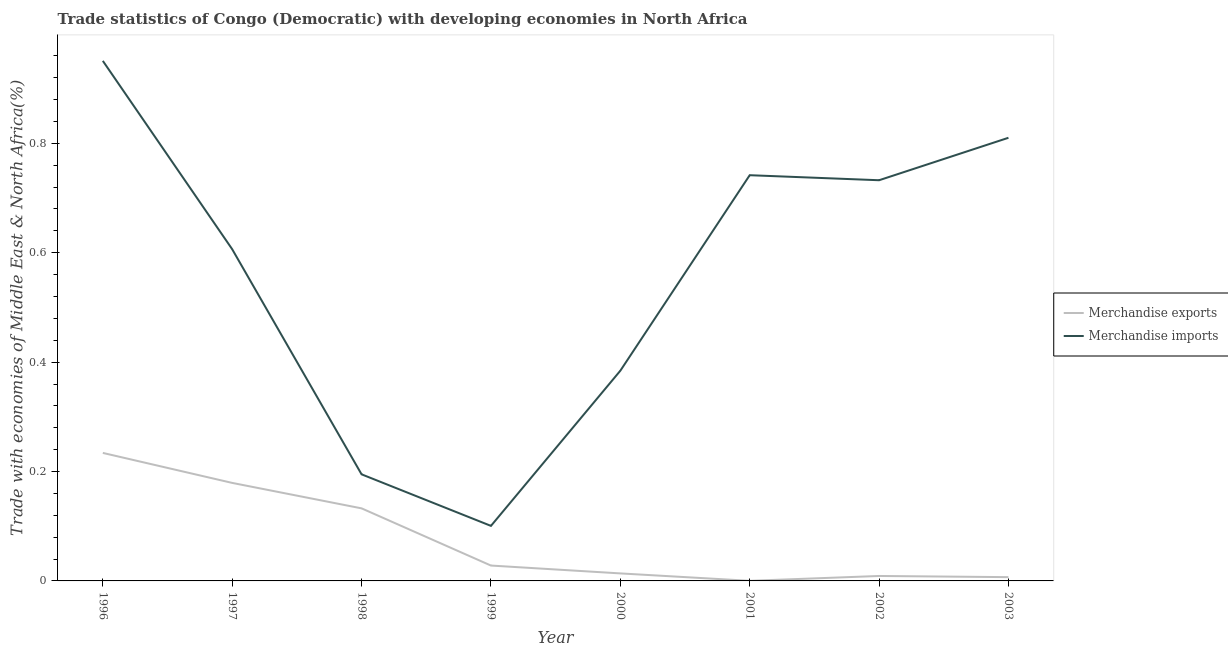What is the merchandise imports in 2003?
Give a very brief answer. 0.81. Across all years, what is the maximum merchandise exports?
Your response must be concise. 0.23. Across all years, what is the minimum merchandise imports?
Provide a succinct answer. 0.1. What is the total merchandise exports in the graph?
Offer a very short reply. 0.6. What is the difference between the merchandise imports in 2000 and that in 2001?
Offer a very short reply. -0.36. What is the difference between the merchandise imports in 2003 and the merchandise exports in 2000?
Give a very brief answer. 0.8. What is the average merchandise exports per year?
Provide a succinct answer. 0.08. In the year 1999, what is the difference between the merchandise imports and merchandise exports?
Give a very brief answer. 0.07. In how many years, is the merchandise imports greater than 0.32 %?
Make the answer very short. 6. What is the ratio of the merchandise imports in 1999 to that in 2002?
Your response must be concise. 0.14. Is the difference between the merchandise imports in 2001 and 2002 greater than the difference between the merchandise exports in 2001 and 2002?
Your response must be concise. Yes. What is the difference between the highest and the second highest merchandise imports?
Offer a very short reply. 0.14. What is the difference between the highest and the lowest merchandise exports?
Your answer should be very brief. 0.23. Is the sum of the merchandise imports in 1998 and 2000 greater than the maximum merchandise exports across all years?
Give a very brief answer. Yes. Does the merchandise imports monotonically increase over the years?
Offer a terse response. No. Is the merchandise exports strictly greater than the merchandise imports over the years?
Provide a short and direct response. No. Is the merchandise imports strictly less than the merchandise exports over the years?
Provide a succinct answer. No. How many years are there in the graph?
Make the answer very short. 8. Are the values on the major ticks of Y-axis written in scientific E-notation?
Keep it short and to the point. No. Does the graph contain any zero values?
Provide a short and direct response. No. Where does the legend appear in the graph?
Provide a short and direct response. Center right. How are the legend labels stacked?
Your response must be concise. Vertical. What is the title of the graph?
Keep it short and to the point. Trade statistics of Congo (Democratic) with developing economies in North Africa. What is the label or title of the X-axis?
Your answer should be very brief. Year. What is the label or title of the Y-axis?
Keep it short and to the point. Trade with economies of Middle East & North Africa(%). What is the Trade with economies of Middle East & North Africa(%) of Merchandise exports in 1996?
Provide a short and direct response. 0.23. What is the Trade with economies of Middle East & North Africa(%) of Merchandise imports in 1996?
Offer a terse response. 0.95. What is the Trade with economies of Middle East & North Africa(%) of Merchandise exports in 1997?
Provide a short and direct response. 0.18. What is the Trade with economies of Middle East & North Africa(%) of Merchandise imports in 1997?
Offer a very short reply. 0.61. What is the Trade with economies of Middle East & North Africa(%) of Merchandise exports in 1998?
Make the answer very short. 0.13. What is the Trade with economies of Middle East & North Africa(%) in Merchandise imports in 1998?
Keep it short and to the point. 0.19. What is the Trade with economies of Middle East & North Africa(%) in Merchandise exports in 1999?
Your response must be concise. 0.03. What is the Trade with economies of Middle East & North Africa(%) in Merchandise imports in 1999?
Provide a succinct answer. 0.1. What is the Trade with economies of Middle East & North Africa(%) of Merchandise exports in 2000?
Provide a short and direct response. 0.01. What is the Trade with economies of Middle East & North Africa(%) of Merchandise imports in 2000?
Make the answer very short. 0.38. What is the Trade with economies of Middle East & North Africa(%) in Merchandise exports in 2001?
Your answer should be very brief. 0. What is the Trade with economies of Middle East & North Africa(%) in Merchandise imports in 2001?
Provide a short and direct response. 0.74. What is the Trade with economies of Middle East & North Africa(%) of Merchandise exports in 2002?
Provide a succinct answer. 0.01. What is the Trade with economies of Middle East & North Africa(%) of Merchandise imports in 2002?
Your answer should be very brief. 0.73. What is the Trade with economies of Middle East & North Africa(%) of Merchandise exports in 2003?
Provide a short and direct response. 0.01. What is the Trade with economies of Middle East & North Africa(%) of Merchandise imports in 2003?
Give a very brief answer. 0.81. Across all years, what is the maximum Trade with economies of Middle East & North Africa(%) of Merchandise exports?
Offer a very short reply. 0.23. Across all years, what is the maximum Trade with economies of Middle East & North Africa(%) in Merchandise imports?
Provide a succinct answer. 0.95. Across all years, what is the minimum Trade with economies of Middle East & North Africa(%) in Merchandise exports?
Give a very brief answer. 0. Across all years, what is the minimum Trade with economies of Middle East & North Africa(%) of Merchandise imports?
Give a very brief answer. 0.1. What is the total Trade with economies of Middle East & North Africa(%) in Merchandise exports in the graph?
Make the answer very short. 0.6. What is the total Trade with economies of Middle East & North Africa(%) of Merchandise imports in the graph?
Your response must be concise. 4.52. What is the difference between the Trade with economies of Middle East & North Africa(%) of Merchandise exports in 1996 and that in 1997?
Offer a terse response. 0.05. What is the difference between the Trade with economies of Middle East & North Africa(%) of Merchandise imports in 1996 and that in 1997?
Offer a very short reply. 0.34. What is the difference between the Trade with economies of Middle East & North Africa(%) of Merchandise exports in 1996 and that in 1998?
Your response must be concise. 0.1. What is the difference between the Trade with economies of Middle East & North Africa(%) in Merchandise imports in 1996 and that in 1998?
Provide a short and direct response. 0.76. What is the difference between the Trade with economies of Middle East & North Africa(%) in Merchandise exports in 1996 and that in 1999?
Ensure brevity in your answer.  0.21. What is the difference between the Trade with economies of Middle East & North Africa(%) of Merchandise imports in 1996 and that in 1999?
Give a very brief answer. 0.85. What is the difference between the Trade with economies of Middle East & North Africa(%) of Merchandise exports in 1996 and that in 2000?
Your response must be concise. 0.22. What is the difference between the Trade with economies of Middle East & North Africa(%) in Merchandise imports in 1996 and that in 2000?
Your answer should be very brief. 0.57. What is the difference between the Trade with economies of Middle East & North Africa(%) in Merchandise exports in 1996 and that in 2001?
Your response must be concise. 0.23. What is the difference between the Trade with economies of Middle East & North Africa(%) in Merchandise imports in 1996 and that in 2001?
Offer a terse response. 0.21. What is the difference between the Trade with economies of Middle East & North Africa(%) in Merchandise exports in 1996 and that in 2002?
Provide a short and direct response. 0.23. What is the difference between the Trade with economies of Middle East & North Africa(%) of Merchandise imports in 1996 and that in 2002?
Your answer should be very brief. 0.22. What is the difference between the Trade with economies of Middle East & North Africa(%) in Merchandise exports in 1996 and that in 2003?
Keep it short and to the point. 0.23. What is the difference between the Trade with economies of Middle East & North Africa(%) in Merchandise imports in 1996 and that in 2003?
Provide a short and direct response. 0.14. What is the difference between the Trade with economies of Middle East & North Africa(%) of Merchandise exports in 1997 and that in 1998?
Offer a terse response. 0.05. What is the difference between the Trade with economies of Middle East & North Africa(%) of Merchandise imports in 1997 and that in 1998?
Provide a succinct answer. 0.41. What is the difference between the Trade with economies of Middle East & North Africa(%) of Merchandise exports in 1997 and that in 1999?
Provide a succinct answer. 0.15. What is the difference between the Trade with economies of Middle East & North Africa(%) in Merchandise imports in 1997 and that in 1999?
Your response must be concise. 0.51. What is the difference between the Trade with economies of Middle East & North Africa(%) of Merchandise exports in 1997 and that in 2000?
Your response must be concise. 0.17. What is the difference between the Trade with economies of Middle East & North Africa(%) in Merchandise imports in 1997 and that in 2000?
Provide a short and direct response. 0.22. What is the difference between the Trade with economies of Middle East & North Africa(%) in Merchandise exports in 1997 and that in 2001?
Your answer should be compact. 0.18. What is the difference between the Trade with economies of Middle East & North Africa(%) in Merchandise imports in 1997 and that in 2001?
Provide a short and direct response. -0.14. What is the difference between the Trade with economies of Middle East & North Africa(%) of Merchandise exports in 1997 and that in 2002?
Offer a very short reply. 0.17. What is the difference between the Trade with economies of Middle East & North Africa(%) in Merchandise imports in 1997 and that in 2002?
Give a very brief answer. -0.13. What is the difference between the Trade with economies of Middle East & North Africa(%) of Merchandise exports in 1997 and that in 2003?
Your response must be concise. 0.17. What is the difference between the Trade with economies of Middle East & North Africa(%) of Merchandise imports in 1997 and that in 2003?
Your response must be concise. -0.2. What is the difference between the Trade with economies of Middle East & North Africa(%) of Merchandise exports in 1998 and that in 1999?
Your answer should be compact. 0.1. What is the difference between the Trade with economies of Middle East & North Africa(%) in Merchandise imports in 1998 and that in 1999?
Provide a short and direct response. 0.09. What is the difference between the Trade with economies of Middle East & North Africa(%) in Merchandise exports in 1998 and that in 2000?
Provide a short and direct response. 0.12. What is the difference between the Trade with economies of Middle East & North Africa(%) of Merchandise imports in 1998 and that in 2000?
Give a very brief answer. -0.19. What is the difference between the Trade with economies of Middle East & North Africa(%) in Merchandise exports in 1998 and that in 2001?
Keep it short and to the point. 0.13. What is the difference between the Trade with economies of Middle East & North Africa(%) of Merchandise imports in 1998 and that in 2001?
Offer a terse response. -0.55. What is the difference between the Trade with economies of Middle East & North Africa(%) of Merchandise exports in 1998 and that in 2002?
Give a very brief answer. 0.12. What is the difference between the Trade with economies of Middle East & North Africa(%) of Merchandise imports in 1998 and that in 2002?
Ensure brevity in your answer.  -0.54. What is the difference between the Trade with economies of Middle East & North Africa(%) of Merchandise exports in 1998 and that in 2003?
Make the answer very short. 0.13. What is the difference between the Trade with economies of Middle East & North Africa(%) of Merchandise imports in 1998 and that in 2003?
Your response must be concise. -0.62. What is the difference between the Trade with economies of Middle East & North Africa(%) of Merchandise exports in 1999 and that in 2000?
Keep it short and to the point. 0.01. What is the difference between the Trade with economies of Middle East & North Africa(%) of Merchandise imports in 1999 and that in 2000?
Provide a short and direct response. -0.28. What is the difference between the Trade with economies of Middle East & North Africa(%) in Merchandise exports in 1999 and that in 2001?
Provide a succinct answer. 0.03. What is the difference between the Trade with economies of Middle East & North Africa(%) of Merchandise imports in 1999 and that in 2001?
Give a very brief answer. -0.64. What is the difference between the Trade with economies of Middle East & North Africa(%) in Merchandise exports in 1999 and that in 2002?
Keep it short and to the point. 0.02. What is the difference between the Trade with economies of Middle East & North Africa(%) in Merchandise imports in 1999 and that in 2002?
Offer a very short reply. -0.63. What is the difference between the Trade with economies of Middle East & North Africa(%) in Merchandise exports in 1999 and that in 2003?
Ensure brevity in your answer.  0.02. What is the difference between the Trade with economies of Middle East & North Africa(%) of Merchandise imports in 1999 and that in 2003?
Your answer should be very brief. -0.71. What is the difference between the Trade with economies of Middle East & North Africa(%) of Merchandise exports in 2000 and that in 2001?
Provide a short and direct response. 0.01. What is the difference between the Trade with economies of Middle East & North Africa(%) in Merchandise imports in 2000 and that in 2001?
Make the answer very short. -0.36. What is the difference between the Trade with economies of Middle East & North Africa(%) of Merchandise exports in 2000 and that in 2002?
Keep it short and to the point. 0. What is the difference between the Trade with economies of Middle East & North Africa(%) in Merchandise imports in 2000 and that in 2002?
Ensure brevity in your answer.  -0.35. What is the difference between the Trade with economies of Middle East & North Africa(%) of Merchandise exports in 2000 and that in 2003?
Provide a succinct answer. 0.01. What is the difference between the Trade with economies of Middle East & North Africa(%) in Merchandise imports in 2000 and that in 2003?
Your answer should be very brief. -0.43. What is the difference between the Trade with economies of Middle East & North Africa(%) in Merchandise exports in 2001 and that in 2002?
Ensure brevity in your answer.  -0.01. What is the difference between the Trade with economies of Middle East & North Africa(%) in Merchandise imports in 2001 and that in 2002?
Your answer should be very brief. 0.01. What is the difference between the Trade with economies of Middle East & North Africa(%) of Merchandise exports in 2001 and that in 2003?
Offer a terse response. -0.01. What is the difference between the Trade with economies of Middle East & North Africa(%) of Merchandise imports in 2001 and that in 2003?
Make the answer very short. -0.07. What is the difference between the Trade with economies of Middle East & North Africa(%) in Merchandise exports in 2002 and that in 2003?
Provide a succinct answer. 0. What is the difference between the Trade with economies of Middle East & North Africa(%) of Merchandise imports in 2002 and that in 2003?
Ensure brevity in your answer.  -0.08. What is the difference between the Trade with economies of Middle East & North Africa(%) in Merchandise exports in 1996 and the Trade with economies of Middle East & North Africa(%) in Merchandise imports in 1997?
Provide a succinct answer. -0.37. What is the difference between the Trade with economies of Middle East & North Africa(%) of Merchandise exports in 1996 and the Trade with economies of Middle East & North Africa(%) of Merchandise imports in 1998?
Your response must be concise. 0.04. What is the difference between the Trade with economies of Middle East & North Africa(%) of Merchandise exports in 1996 and the Trade with economies of Middle East & North Africa(%) of Merchandise imports in 1999?
Your answer should be compact. 0.13. What is the difference between the Trade with economies of Middle East & North Africa(%) in Merchandise exports in 1996 and the Trade with economies of Middle East & North Africa(%) in Merchandise imports in 2000?
Your response must be concise. -0.15. What is the difference between the Trade with economies of Middle East & North Africa(%) of Merchandise exports in 1996 and the Trade with economies of Middle East & North Africa(%) of Merchandise imports in 2001?
Give a very brief answer. -0.51. What is the difference between the Trade with economies of Middle East & North Africa(%) in Merchandise exports in 1996 and the Trade with economies of Middle East & North Africa(%) in Merchandise imports in 2002?
Give a very brief answer. -0.5. What is the difference between the Trade with economies of Middle East & North Africa(%) in Merchandise exports in 1996 and the Trade with economies of Middle East & North Africa(%) in Merchandise imports in 2003?
Make the answer very short. -0.58. What is the difference between the Trade with economies of Middle East & North Africa(%) of Merchandise exports in 1997 and the Trade with economies of Middle East & North Africa(%) of Merchandise imports in 1998?
Your answer should be very brief. -0.02. What is the difference between the Trade with economies of Middle East & North Africa(%) of Merchandise exports in 1997 and the Trade with economies of Middle East & North Africa(%) of Merchandise imports in 1999?
Provide a short and direct response. 0.08. What is the difference between the Trade with economies of Middle East & North Africa(%) in Merchandise exports in 1997 and the Trade with economies of Middle East & North Africa(%) in Merchandise imports in 2000?
Give a very brief answer. -0.21. What is the difference between the Trade with economies of Middle East & North Africa(%) in Merchandise exports in 1997 and the Trade with economies of Middle East & North Africa(%) in Merchandise imports in 2001?
Keep it short and to the point. -0.56. What is the difference between the Trade with economies of Middle East & North Africa(%) of Merchandise exports in 1997 and the Trade with economies of Middle East & North Africa(%) of Merchandise imports in 2002?
Offer a very short reply. -0.55. What is the difference between the Trade with economies of Middle East & North Africa(%) in Merchandise exports in 1997 and the Trade with economies of Middle East & North Africa(%) in Merchandise imports in 2003?
Make the answer very short. -0.63. What is the difference between the Trade with economies of Middle East & North Africa(%) of Merchandise exports in 1998 and the Trade with economies of Middle East & North Africa(%) of Merchandise imports in 1999?
Keep it short and to the point. 0.03. What is the difference between the Trade with economies of Middle East & North Africa(%) in Merchandise exports in 1998 and the Trade with economies of Middle East & North Africa(%) in Merchandise imports in 2000?
Keep it short and to the point. -0.25. What is the difference between the Trade with economies of Middle East & North Africa(%) in Merchandise exports in 1998 and the Trade with economies of Middle East & North Africa(%) in Merchandise imports in 2001?
Give a very brief answer. -0.61. What is the difference between the Trade with economies of Middle East & North Africa(%) in Merchandise exports in 1998 and the Trade with economies of Middle East & North Africa(%) in Merchandise imports in 2002?
Provide a short and direct response. -0.6. What is the difference between the Trade with economies of Middle East & North Africa(%) of Merchandise exports in 1998 and the Trade with economies of Middle East & North Africa(%) of Merchandise imports in 2003?
Provide a short and direct response. -0.68. What is the difference between the Trade with economies of Middle East & North Africa(%) in Merchandise exports in 1999 and the Trade with economies of Middle East & North Africa(%) in Merchandise imports in 2000?
Give a very brief answer. -0.36. What is the difference between the Trade with economies of Middle East & North Africa(%) in Merchandise exports in 1999 and the Trade with economies of Middle East & North Africa(%) in Merchandise imports in 2001?
Provide a short and direct response. -0.71. What is the difference between the Trade with economies of Middle East & North Africa(%) of Merchandise exports in 1999 and the Trade with economies of Middle East & North Africa(%) of Merchandise imports in 2002?
Your answer should be very brief. -0.7. What is the difference between the Trade with economies of Middle East & North Africa(%) in Merchandise exports in 1999 and the Trade with economies of Middle East & North Africa(%) in Merchandise imports in 2003?
Your answer should be compact. -0.78. What is the difference between the Trade with economies of Middle East & North Africa(%) in Merchandise exports in 2000 and the Trade with economies of Middle East & North Africa(%) in Merchandise imports in 2001?
Offer a terse response. -0.73. What is the difference between the Trade with economies of Middle East & North Africa(%) of Merchandise exports in 2000 and the Trade with economies of Middle East & North Africa(%) of Merchandise imports in 2002?
Offer a terse response. -0.72. What is the difference between the Trade with economies of Middle East & North Africa(%) of Merchandise exports in 2000 and the Trade with economies of Middle East & North Africa(%) of Merchandise imports in 2003?
Offer a terse response. -0.8. What is the difference between the Trade with economies of Middle East & North Africa(%) in Merchandise exports in 2001 and the Trade with economies of Middle East & North Africa(%) in Merchandise imports in 2002?
Keep it short and to the point. -0.73. What is the difference between the Trade with economies of Middle East & North Africa(%) in Merchandise exports in 2001 and the Trade with economies of Middle East & North Africa(%) in Merchandise imports in 2003?
Offer a terse response. -0.81. What is the difference between the Trade with economies of Middle East & North Africa(%) in Merchandise exports in 2002 and the Trade with economies of Middle East & North Africa(%) in Merchandise imports in 2003?
Offer a terse response. -0.8. What is the average Trade with economies of Middle East & North Africa(%) of Merchandise exports per year?
Offer a terse response. 0.08. What is the average Trade with economies of Middle East & North Africa(%) in Merchandise imports per year?
Keep it short and to the point. 0.57. In the year 1996, what is the difference between the Trade with economies of Middle East & North Africa(%) in Merchandise exports and Trade with economies of Middle East & North Africa(%) in Merchandise imports?
Make the answer very short. -0.72. In the year 1997, what is the difference between the Trade with economies of Middle East & North Africa(%) in Merchandise exports and Trade with economies of Middle East & North Africa(%) in Merchandise imports?
Your answer should be very brief. -0.43. In the year 1998, what is the difference between the Trade with economies of Middle East & North Africa(%) of Merchandise exports and Trade with economies of Middle East & North Africa(%) of Merchandise imports?
Keep it short and to the point. -0.06. In the year 1999, what is the difference between the Trade with economies of Middle East & North Africa(%) of Merchandise exports and Trade with economies of Middle East & North Africa(%) of Merchandise imports?
Your answer should be very brief. -0.07. In the year 2000, what is the difference between the Trade with economies of Middle East & North Africa(%) in Merchandise exports and Trade with economies of Middle East & North Africa(%) in Merchandise imports?
Provide a succinct answer. -0.37. In the year 2001, what is the difference between the Trade with economies of Middle East & North Africa(%) of Merchandise exports and Trade with economies of Middle East & North Africa(%) of Merchandise imports?
Give a very brief answer. -0.74. In the year 2002, what is the difference between the Trade with economies of Middle East & North Africa(%) in Merchandise exports and Trade with economies of Middle East & North Africa(%) in Merchandise imports?
Make the answer very short. -0.72. In the year 2003, what is the difference between the Trade with economies of Middle East & North Africa(%) of Merchandise exports and Trade with economies of Middle East & North Africa(%) of Merchandise imports?
Your answer should be very brief. -0.8. What is the ratio of the Trade with economies of Middle East & North Africa(%) in Merchandise exports in 1996 to that in 1997?
Ensure brevity in your answer.  1.31. What is the ratio of the Trade with economies of Middle East & North Africa(%) in Merchandise imports in 1996 to that in 1997?
Keep it short and to the point. 1.57. What is the ratio of the Trade with economies of Middle East & North Africa(%) of Merchandise exports in 1996 to that in 1998?
Your response must be concise. 1.76. What is the ratio of the Trade with economies of Middle East & North Africa(%) in Merchandise imports in 1996 to that in 1998?
Keep it short and to the point. 4.88. What is the ratio of the Trade with economies of Middle East & North Africa(%) of Merchandise exports in 1996 to that in 1999?
Your response must be concise. 8.33. What is the ratio of the Trade with economies of Middle East & North Africa(%) in Merchandise imports in 1996 to that in 1999?
Provide a succinct answer. 9.45. What is the ratio of the Trade with economies of Middle East & North Africa(%) of Merchandise exports in 1996 to that in 2000?
Provide a succinct answer. 17.02. What is the ratio of the Trade with economies of Middle East & North Africa(%) of Merchandise imports in 1996 to that in 2000?
Offer a very short reply. 2.47. What is the ratio of the Trade with economies of Middle East & North Africa(%) of Merchandise exports in 1996 to that in 2001?
Provide a succinct answer. 1125.14. What is the ratio of the Trade with economies of Middle East & North Africa(%) of Merchandise imports in 1996 to that in 2001?
Make the answer very short. 1.28. What is the ratio of the Trade with economies of Middle East & North Africa(%) of Merchandise exports in 1996 to that in 2002?
Give a very brief answer. 25.85. What is the ratio of the Trade with economies of Middle East & North Africa(%) in Merchandise imports in 1996 to that in 2002?
Provide a short and direct response. 1.3. What is the ratio of the Trade with economies of Middle East & North Africa(%) of Merchandise exports in 1996 to that in 2003?
Make the answer very short. 33.84. What is the ratio of the Trade with economies of Middle East & North Africa(%) of Merchandise imports in 1996 to that in 2003?
Offer a terse response. 1.17. What is the ratio of the Trade with economies of Middle East & North Africa(%) in Merchandise exports in 1997 to that in 1998?
Give a very brief answer. 1.35. What is the ratio of the Trade with economies of Middle East & North Africa(%) of Merchandise imports in 1997 to that in 1998?
Offer a terse response. 3.11. What is the ratio of the Trade with economies of Middle East & North Africa(%) in Merchandise exports in 1997 to that in 1999?
Provide a short and direct response. 6.38. What is the ratio of the Trade with economies of Middle East & North Africa(%) in Merchandise imports in 1997 to that in 1999?
Give a very brief answer. 6.03. What is the ratio of the Trade with economies of Middle East & North Africa(%) of Merchandise exports in 1997 to that in 2000?
Your answer should be compact. 13.03. What is the ratio of the Trade with economies of Middle East & North Africa(%) of Merchandise imports in 1997 to that in 2000?
Give a very brief answer. 1.58. What is the ratio of the Trade with economies of Middle East & North Africa(%) of Merchandise exports in 1997 to that in 2001?
Provide a short and direct response. 861.53. What is the ratio of the Trade with economies of Middle East & North Africa(%) of Merchandise imports in 1997 to that in 2001?
Make the answer very short. 0.82. What is the ratio of the Trade with economies of Middle East & North Africa(%) in Merchandise exports in 1997 to that in 2002?
Keep it short and to the point. 19.79. What is the ratio of the Trade with economies of Middle East & North Africa(%) in Merchandise imports in 1997 to that in 2002?
Keep it short and to the point. 0.83. What is the ratio of the Trade with economies of Middle East & North Africa(%) of Merchandise exports in 1997 to that in 2003?
Give a very brief answer. 25.91. What is the ratio of the Trade with economies of Middle East & North Africa(%) of Merchandise imports in 1997 to that in 2003?
Offer a very short reply. 0.75. What is the ratio of the Trade with economies of Middle East & North Africa(%) in Merchandise exports in 1998 to that in 1999?
Your answer should be compact. 4.72. What is the ratio of the Trade with economies of Middle East & North Africa(%) in Merchandise imports in 1998 to that in 1999?
Offer a very short reply. 1.94. What is the ratio of the Trade with economies of Middle East & North Africa(%) in Merchandise exports in 1998 to that in 2000?
Provide a succinct answer. 9.65. What is the ratio of the Trade with economies of Middle East & North Africa(%) of Merchandise imports in 1998 to that in 2000?
Your answer should be compact. 0.51. What is the ratio of the Trade with economies of Middle East & North Africa(%) in Merchandise exports in 1998 to that in 2001?
Offer a very short reply. 637.8. What is the ratio of the Trade with economies of Middle East & North Africa(%) of Merchandise imports in 1998 to that in 2001?
Ensure brevity in your answer.  0.26. What is the ratio of the Trade with economies of Middle East & North Africa(%) of Merchandise exports in 1998 to that in 2002?
Provide a short and direct response. 14.65. What is the ratio of the Trade with economies of Middle East & North Africa(%) of Merchandise imports in 1998 to that in 2002?
Your response must be concise. 0.27. What is the ratio of the Trade with economies of Middle East & North Africa(%) of Merchandise exports in 1998 to that in 2003?
Offer a terse response. 19.18. What is the ratio of the Trade with economies of Middle East & North Africa(%) in Merchandise imports in 1998 to that in 2003?
Keep it short and to the point. 0.24. What is the ratio of the Trade with economies of Middle East & North Africa(%) in Merchandise exports in 1999 to that in 2000?
Ensure brevity in your answer.  2.04. What is the ratio of the Trade with economies of Middle East & North Africa(%) in Merchandise imports in 1999 to that in 2000?
Give a very brief answer. 0.26. What is the ratio of the Trade with economies of Middle East & North Africa(%) of Merchandise exports in 1999 to that in 2001?
Keep it short and to the point. 135.12. What is the ratio of the Trade with economies of Middle East & North Africa(%) in Merchandise imports in 1999 to that in 2001?
Provide a short and direct response. 0.14. What is the ratio of the Trade with economies of Middle East & North Africa(%) in Merchandise exports in 1999 to that in 2002?
Make the answer very short. 3.1. What is the ratio of the Trade with economies of Middle East & North Africa(%) of Merchandise imports in 1999 to that in 2002?
Keep it short and to the point. 0.14. What is the ratio of the Trade with economies of Middle East & North Africa(%) in Merchandise exports in 1999 to that in 2003?
Provide a succinct answer. 4.06. What is the ratio of the Trade with economies of Middle East & North Africa(%) in Merchandise imports in 1999 to that in 2003?
Give a very brief answer. 0.12. What is the ratio of the Trade with economies of Middle East & North Africa(%) in Merchandise exports in 2000 to that in 2001?
Offer a terse response. 66.1. What is the ratio of the Trade with economies of Middle East & North Africa(%) in Merchandise imports in 2000 to that in 2001?
Give a very brief answer. 0.52. What is the ratio of the Trade with economies of Middle East & North Africa(%) of Merchandise exports in 2000 to that in 2002?
Your answer should be compact. 1.52. What is the ratio of the Trade with economies of Middle East & North Africa(%) in Merchandise imports in 2000 to that in 2002?
Your answer should be compact. 0.52. What is the ratio of the Trade with economies of Middle East & North Africa(%) of Merchandise exports in 2000 to that in 2003?
Provide a short and direct response. 1.99. What is the ratio of the Trade with economies of Middle East & North Africa(%) in Merchandise imports in 2000 to that in 2003?
Your answer should be very brief. 0.47. What is the ratio of the Trade with economies of Middle East & North Africa(%) of Merchandise exports in 2001 to that in 2002?
Keep it short and to the point. 0.02. What is the ratio of the Trade with economies of Middle East & North Africa(%) of Merchandise imports in 2001 to that in 2002?
Make the answer very short. 1.01. What is the ratio of the Trade with economies of Middle East & North Africa(%) in Merchandise exports in 2001 to that in 2003?
Your answer should be compact. 0.03. What is the ratio of the Trade with economies of Middle East & North Africa(%) of Merchandise imports in 2001 to that in 2003?
Give a very brief answer. 0.92. What is the ratio of the Trade with economies of Middle East & North Africa(%) of Merchandise exports in 2002 to that in 2003?
Your answer should be compact. 1.31. What is the ratio of the Trade with economies of Middle East & North Africa(%) in Merchandise imports in 2002 to that in 2003?
Provide a succinct answer. 0.9. What is the difference between the highest and the second highest Trade with economies of Middle East & North Africa(%) of Merchandise exports?
Your answer should be very brief. 0.05. What is the difference between the highest and the second highest Trade with economies of Middle East & North Africa(%) of Merchandise imports?
Your response must be concise. 0.14. What is the difference between the highest and the lowest Trade with economies of Middle East & North Africa(%) of Merchandise exports?
Offer a terse response. 0.23. What is the difference between the highest and the lowest Trade with economies of Middle East & North Africa(%) in Merchandise imports?
Keep it short and to the point. 0.85. 